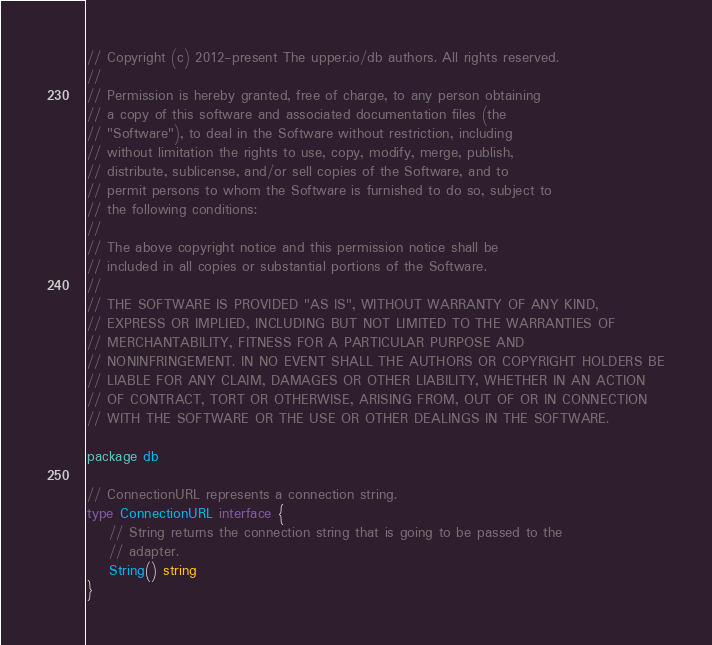<code> <loc_0><loc_0><loc_500><loc_500><_Go_>// Copyright (c) 2012-present The upper.io/db authors. All rights reserved.
//
// Permission is hereby granted, free of charge, to any person obtaining
// a copy of this software and associated documentation files (the
// "Software"), to deal in the Software without restriction, including
// without limitation the rights to use, copy, modify, merge, publish,
// distribute, sublicense, and/or sell copies of the Software, and to
// permit persons to whom the Software is furnished to do so, subject to
// the following conditions:
//
// The above copyright notice and this permission notice shall be
// included in all copies or substantial portions of the Software.
//
// THE SOFTWARE IS PROVIDED "AS IS", WITHOUT WARRANTY OF ANY KIND,
// EXPRESS OR IMPLIED, INCLUDING BUT NOT LIMITED TO THE WARRANTIES OF
// MERCHANTABILITY, FITNESS FOR A PARTICULAR PURPOSE AND
// NONINFRINGEMENT. IN NO EVENT SHALL THE AUTHORS OR COPYRIGHT HOLDERS BE
// LIABLE FOR ANY CLAIM, DAMAGES OR OTHER LIABILITY, WHETHER IN AN ACTION
// OF CONTRACT, TORT OR OTHERWISE, ARISING FROM, OUT OF OR IN CONNECTION
// WITH THE SOFTWARE OR THE USE OR OTHER DEALINGS IN THE SOFTWARE.

package db

// ConnectionURL represents a connection string.
type ConnectionURL interface {
	// String returns the connection string that is going to be passed to the
	// adapter.
	String() string
}
</code> 